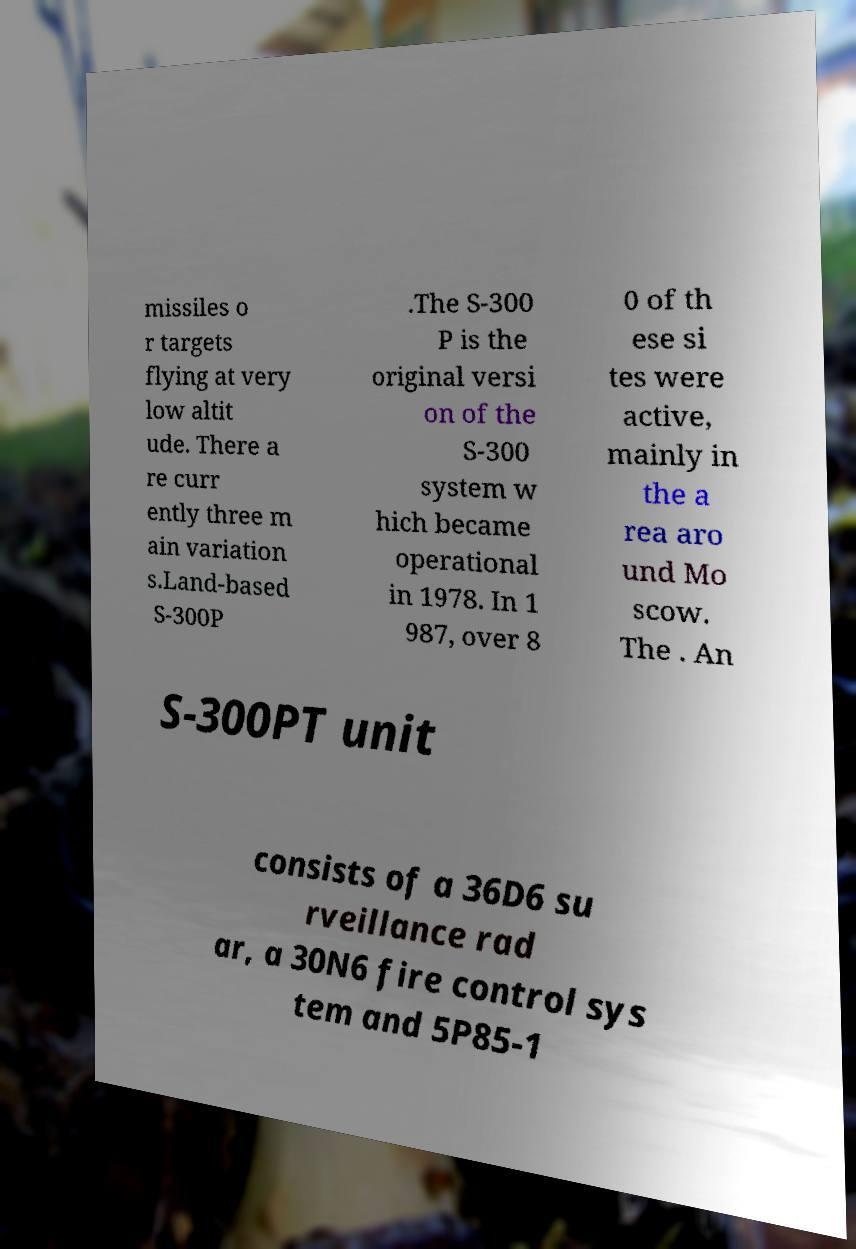Please identify and transcribe the text found in this image. missiles o r targets flying at very low altit ude. There a re curr ently three m ain variation s.Land-based S-300P .The S-300 P is the original versi on of the S-300 system w hich became operational in 1978. In 1 987, over 8 0 of th ese si tes were active, mainly in the a rea aro und Mo scow. The . An S-300PT unit consists of a 36D6 su rveillance rad ar, a 30N6 fire control sys tem and 5P85-1 